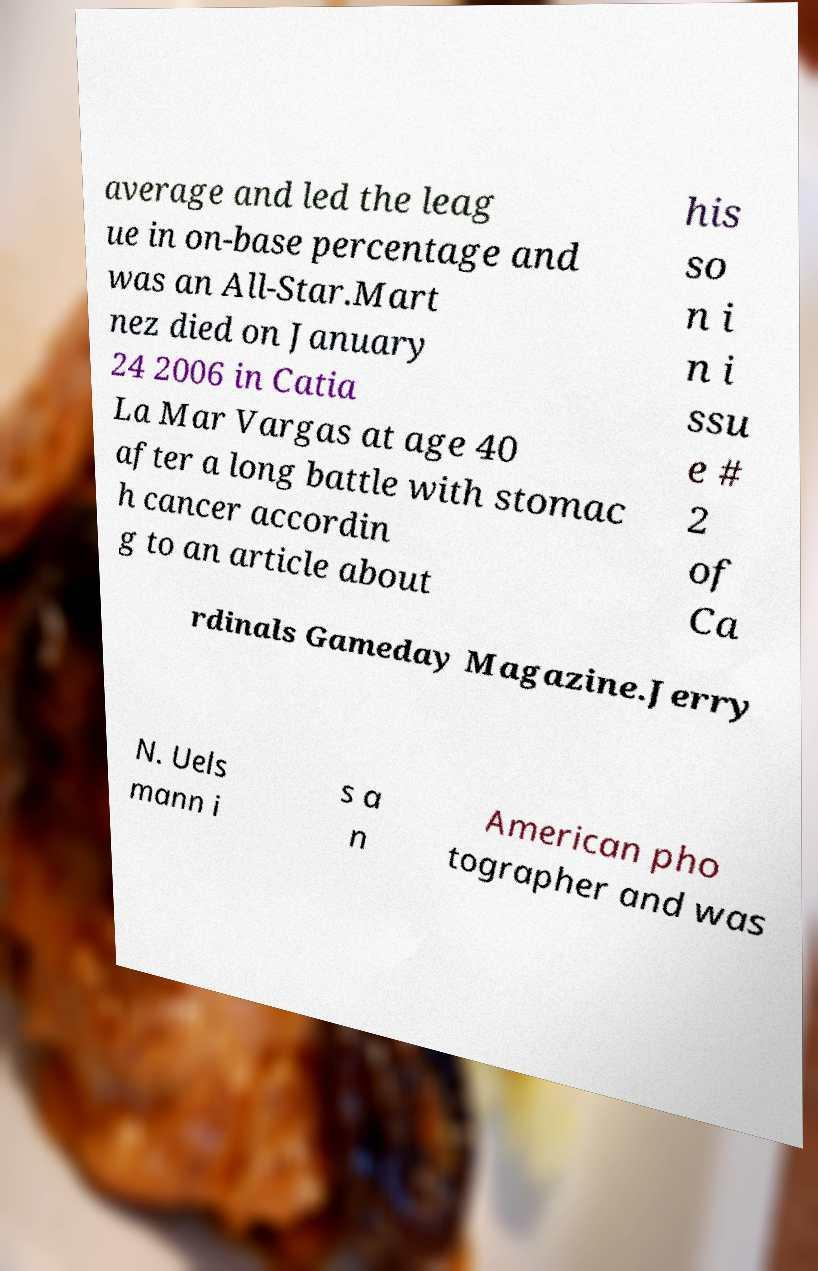There's text embedded in this image that I need extracted. Can you transcribe it verbatim? average and led the leag ue in on-base percentage and was an All-Star.Mart nez died on January 24 2006 in Catia La Mar Vargas at age 40 after a long battle with stomac h cancer accordin g to an article about his so n i n i ssu e # 2 of Ca rdinals Gameday Magazine.Jerry N. Uels mann i s a n American pho tographer and was 